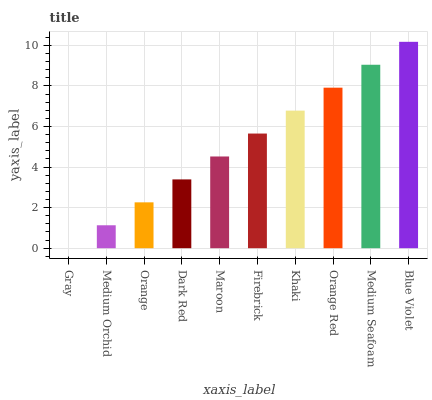Is Gray the minimum?
Answer yes or no. Yes. Is Blue Violet the maximum?
Answer yes or no. Yes. Is Medium Orchid the minimum?
Answer yes or no. No. Is Medium Orchid the maximum?
Answer yes or no. No. Is Medium Orchid greater than Gray?
Answer yes or no. Yes. Is Gray less than Medium Orchid?
Answer yes or no. Yes. Is Gray greater than Medium Orchid?
Answer yes or no. No. Is Medium Orchid less than Gray?
Answer yes or no. No. Is Firebrick the high median?
Answer yes or no. Yes. Is Maroon the low median?
Answer yes or no. Yes. Is Blue Violet the high median?
Answer yes or no. No. Is Blue Violet the low median?
Answer yes or no. No. 